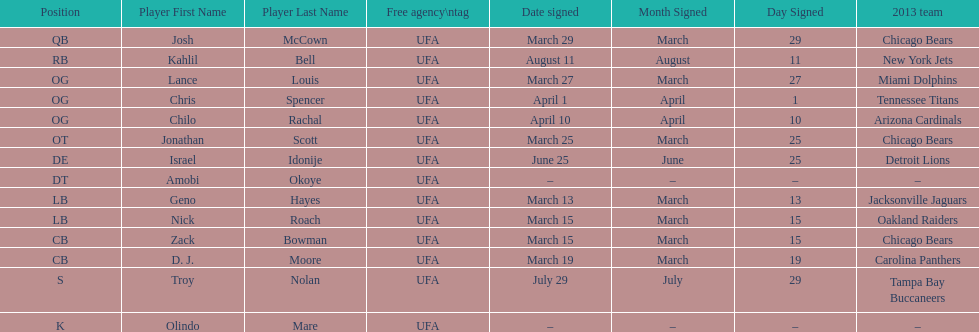Nick roach was signed the same day as what other player? Zack Bowman. 